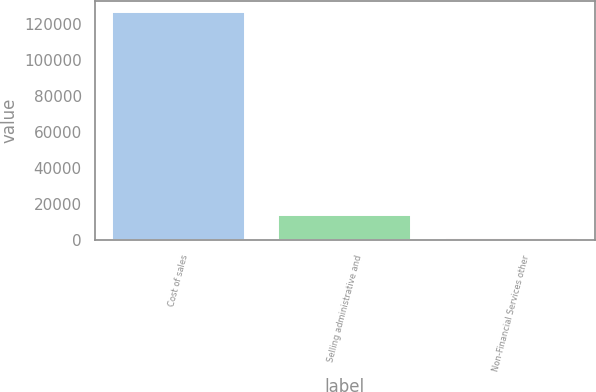<chart> <loc_0><loc_0><loc_500><loc_500><bar_chart><fcel>Cost of sales<fcel>Selling administrative and<fcel>Non-Financial Services other<nl><fcel>126584<fcel>13878.8<fcel>1356<nl></chart> 